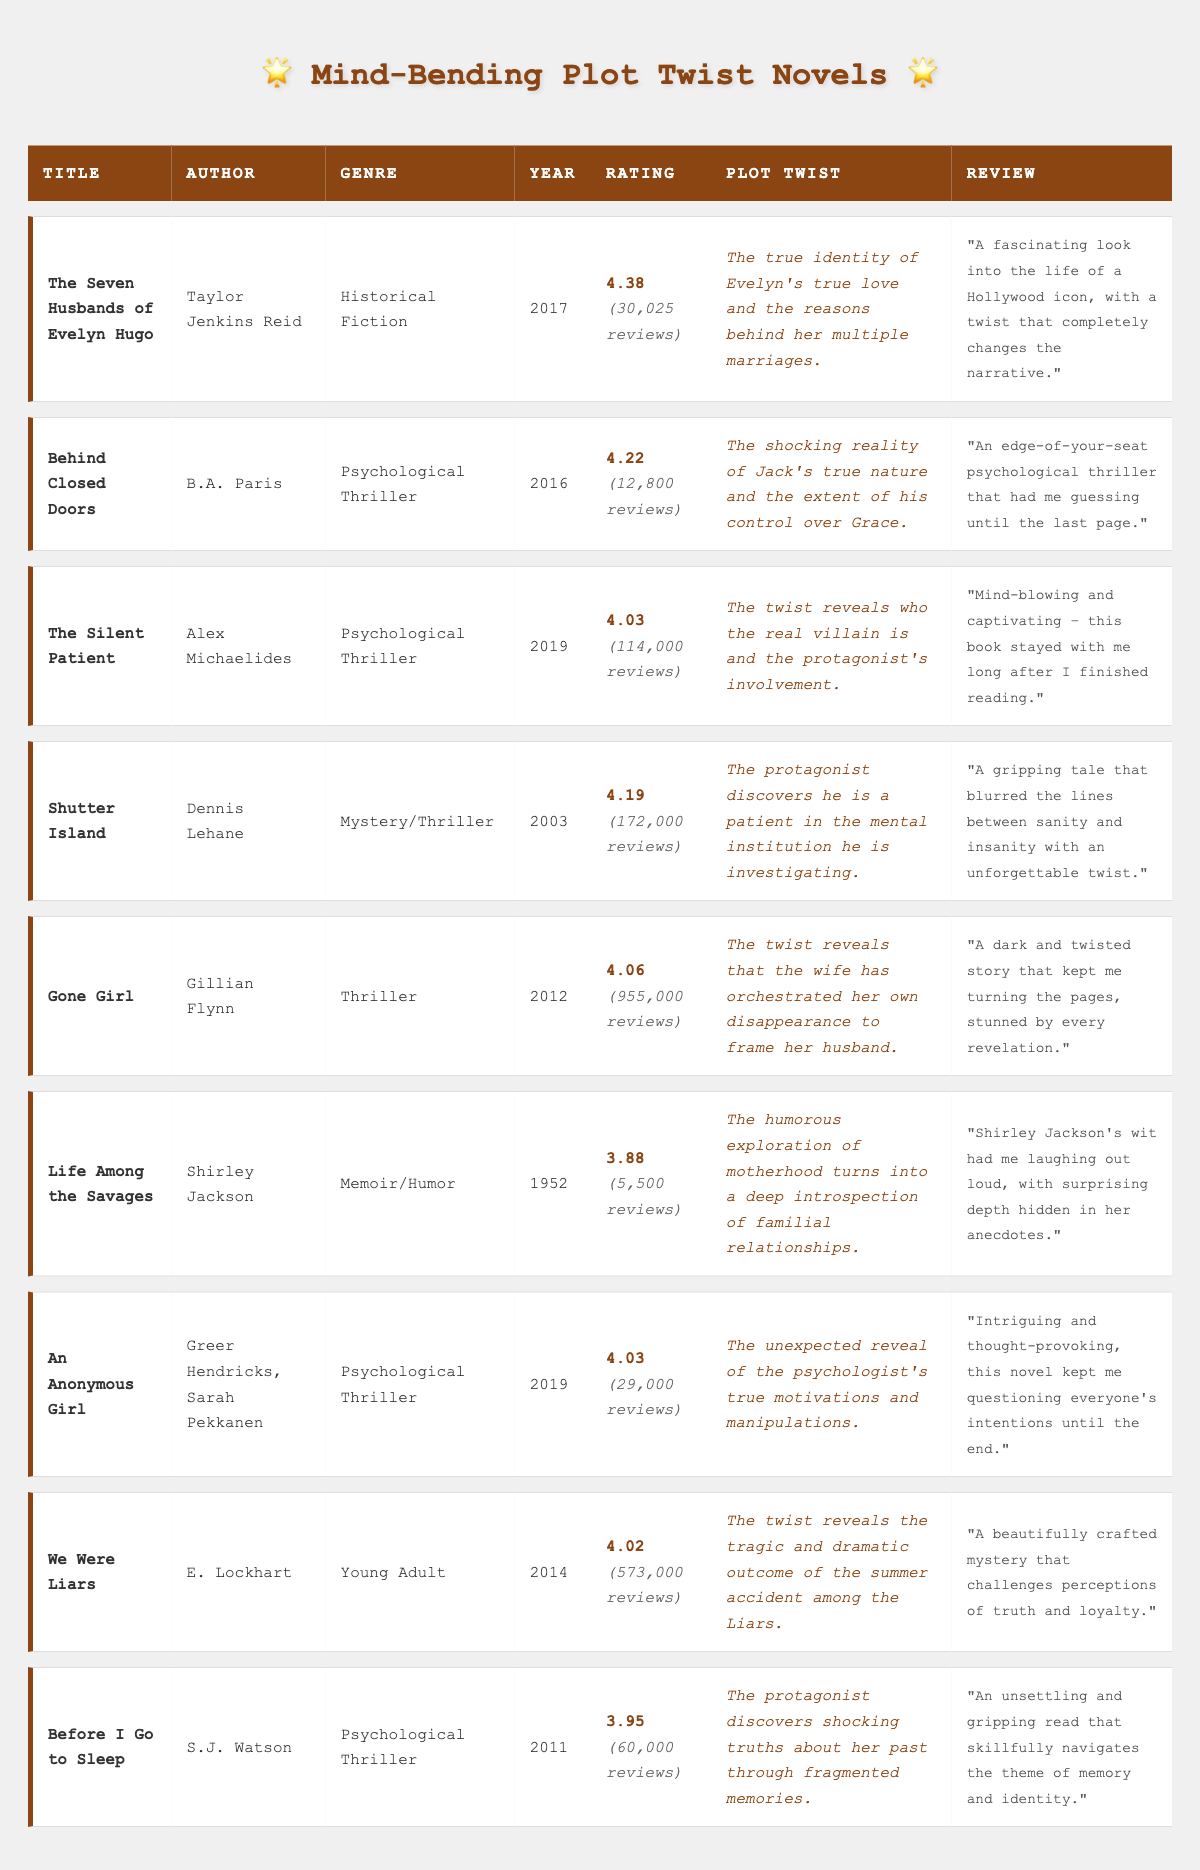What is the reader rating of "Gone Girl"? The table lists the reader rating for "Gone Girl", which is directly provided in the rating column. The value is 4.06.
Answer: 4.06 How many reviews does "The Silent Patient" have? Referring to the review count column in the table, "The Silent Patient" has a total of 114,000 reviews.
Answer: 114,000 Which book has the highest reader rating? To find the book with the highest rating, we can compare the rating column for each title. "The Seven Husbands of Evelyn Hugo" has the highest rating at 4.38.
Answer: The Seven Husbands of Evelyn Hugo Are there more reviews for "Life Among the Savages" compared to "An Anonymous Girl"? First, we look at the review counts: "Life Among the Savages" has 5,500 reviews, while "An Anonymous Girl" has 29,000 reviews. Since 5,500 is less than 29,000, the statement is false.
Answer: No What is the average reader rating of the Psychological Thriller genre? To calculate the average rating, we first identify all books within the Psychological Thriller genre: "Behind Closed Doors" (4.22), "The Silent Patient" (4.03), "An Anonymous Girl" (4.03), and "Before I Go to Sleep" (3.95). Summing these ratings gives us: 4.22 + 4.03 + 4.03 + 3.95 = 16.23. There are 4 books, so the average is 16.23 / 4 = 4.0575, which can be rounded to 4.06.
Answer: 4.06 How many total reviews are there across all books listed in the table? To find the total number of reviews, add the review counts of each book. The counts are: 30,025 + 12,800 + 114,000 + 172,000 + 955,000 + 5,500 + 29,000 + 573,000 + 60,000 = 2,036,325.
Answer: 2,036,325 Which author has written the oldest book on the list? To determine the oldest publication, compare the published years. "Life Among the Savages" published in 1952 is the oldest compared to other publication years noted in the table.
Answer: Shirley Jackson Does "We Were Liars" have a plot twist related to an accident? Check the plot twist for "We Were Liars" which states: "The twist reveals the tragic and dramatic outcome of the summer accident among the Liars." Therefore, this is true.
Answer: Yes Which two books have the most similar reader ratings? Examine the ratings of the books. "The Silent Patient" and "An Anonymous Girl" both have a rating of 4.03, which is the closest match.
Answer: The Silent Patient and An Anonymous Girl 